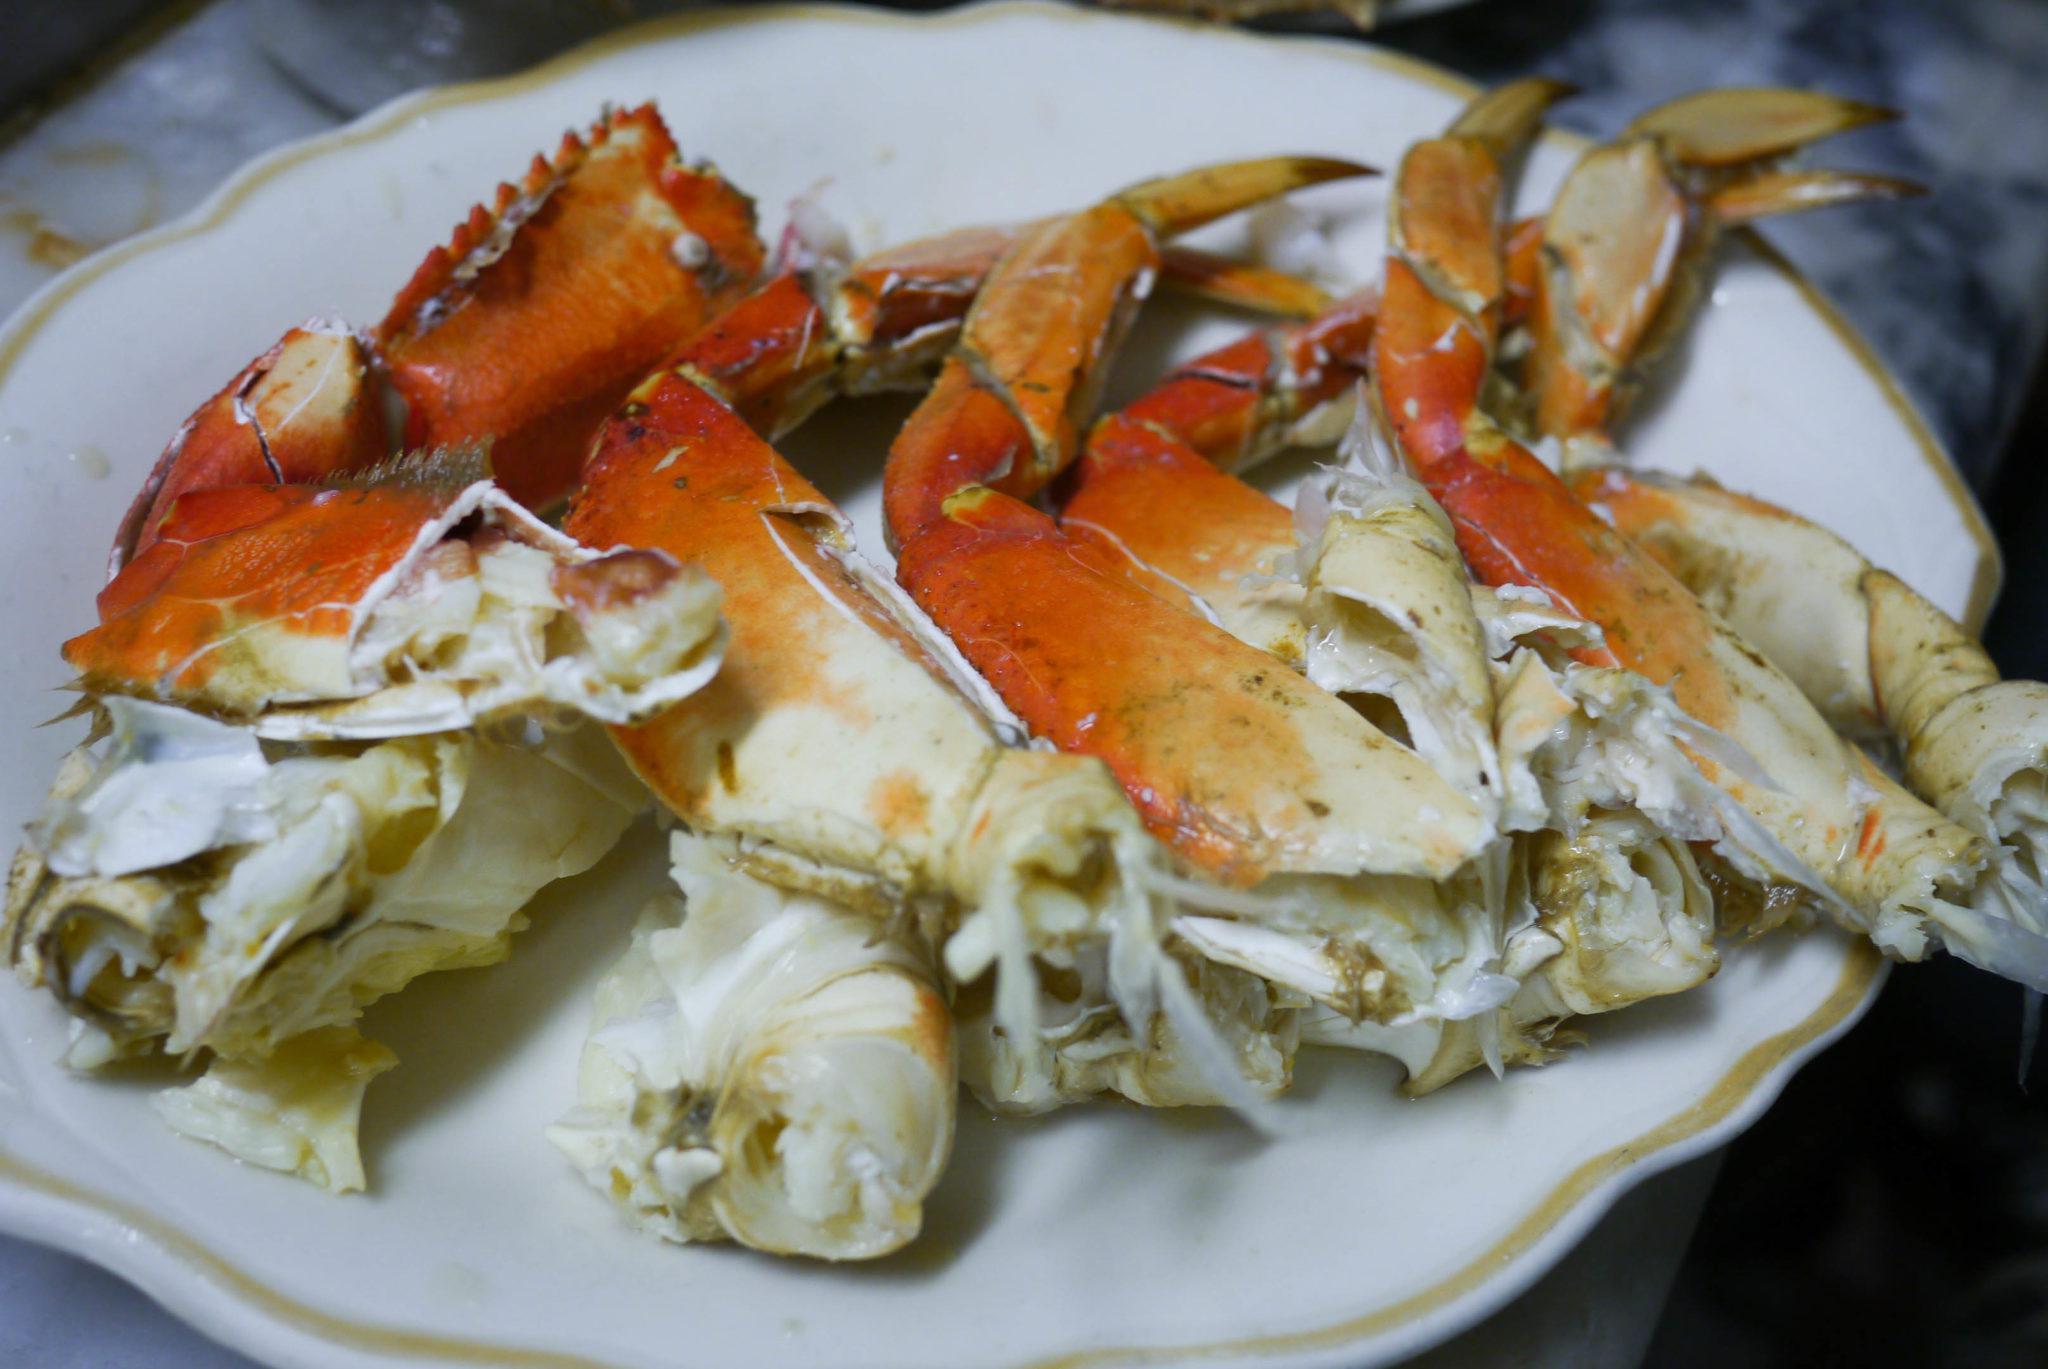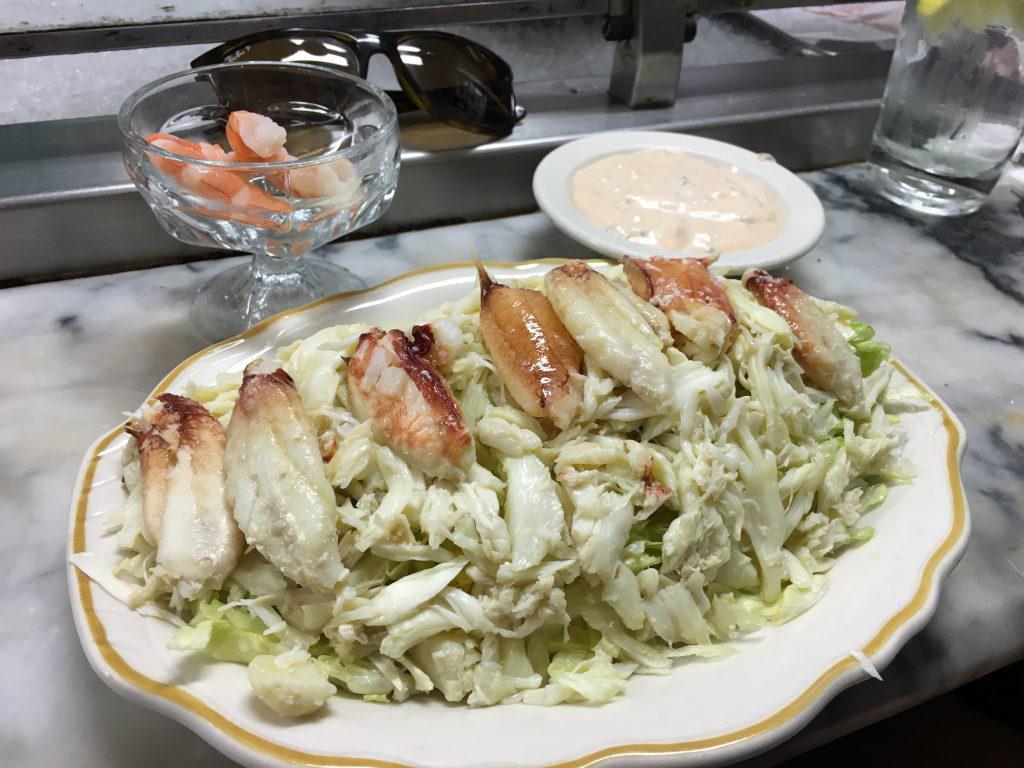The first image is the image on the left, the second image is the image on the right. For the images shown, is this caption "In the image on the left, there is a dish containing only crab legs." true? Answer yes or no. Yes. The first image is the image on the left, the second image is the image on the right. Assess this claim about the two images: "The left image shows a hollowed-out crab shell on a gold-rimmed plate with yellowish broth inside.". Correct or not? Answer yes or no. No. 